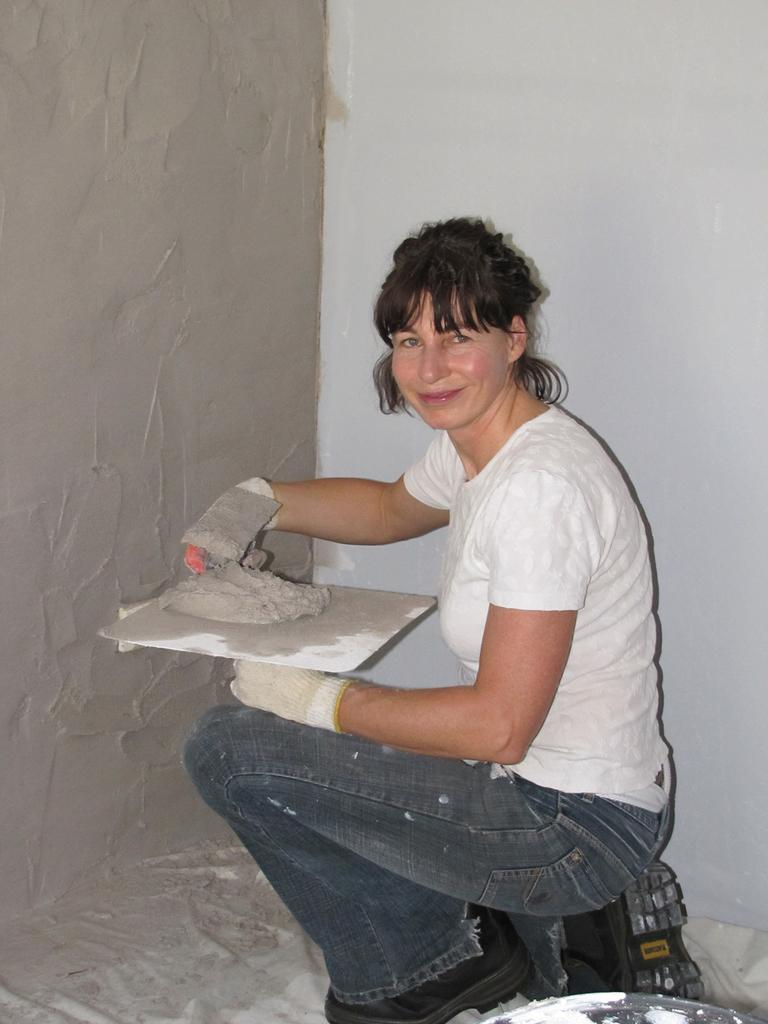Who is the main subject in the image? There is a woman in the image. What is the woman wearing? The woman is wearing a white t-shirt. Where is the woman sitting in the image? The woman is sitting in the front. What is the woman holding in her hand? The woman is holding a plaster in her hand. What type of wall can be seen in the background of the image? There is a plaster wall visible in the background of the image. What type of story is the woman reading in the image? There is no story visible in the image; the woman is holding a plaster in her hand. What type of underwear is the woman wearing in the image? The provided facts do not mention the woman's underwear, and it cannot be determined from the image. 